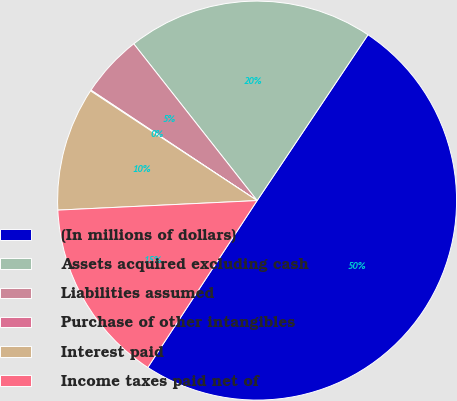<chart> <loc_0><loc_0><loc_500><loc_500><pie_chart><fcel>(In millions of dollars)<fcel>Assets acquired excluding cash<fcel>Liabilities assumed<fcel>Purchase of other intangibles<fcel>Interest paid<fcel>Income taxes paid net of<nl><fcel>49.85%<fcel>19.99%<fcel>5.05%<fcel>0.07%<fcel>10.03%<fcel>15.01%<nl></chart> 